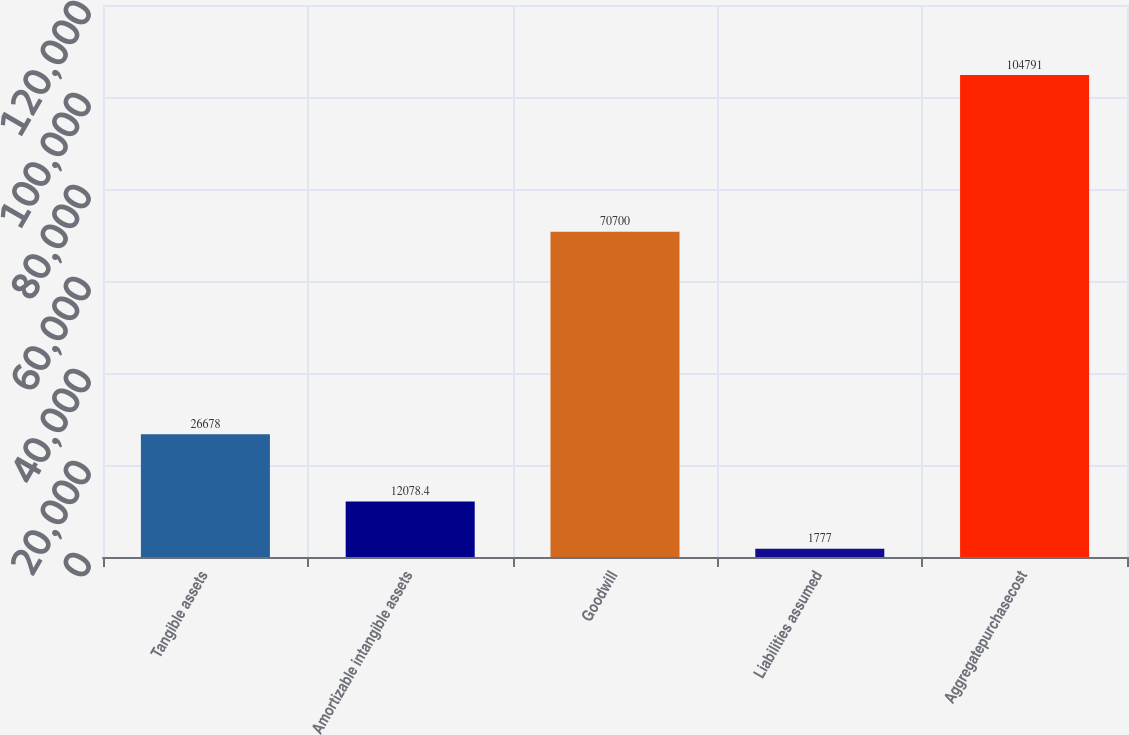Convert chart. <chart><loc_0><loc_0><loc_500><loc_500><bar_chart><fcel>Tangible assets<fcel>Amortizable intangible assets<fcel>Goodwill<fcel>Liabilities assumed<fcel>Aggregatepurchasecost<nl><fcel>26678<fcel>12078.4<fcel>70700<fcel>1777<fcel>104791<nl></chart> 